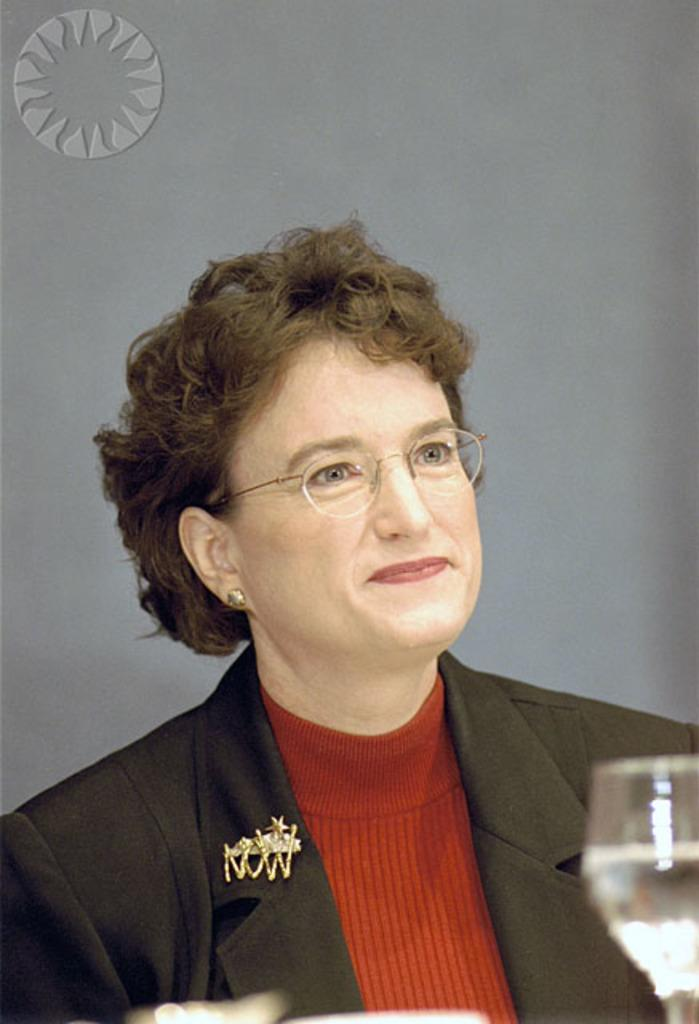Who is present in the image? There is a woman in the image. What is the woman doing in the image? The woman is smiling in the image. What accessory is the woman wearing? The woman is wearing spectacles in the image. What object can be seen in the image besides the woman? There is a glass in the image. What color is the background of the image? The background of the image is grey. What type of copper material can be seen in the image? There is no copper material present in the image. What does the queen do in the image? There is no queen present in the image. 